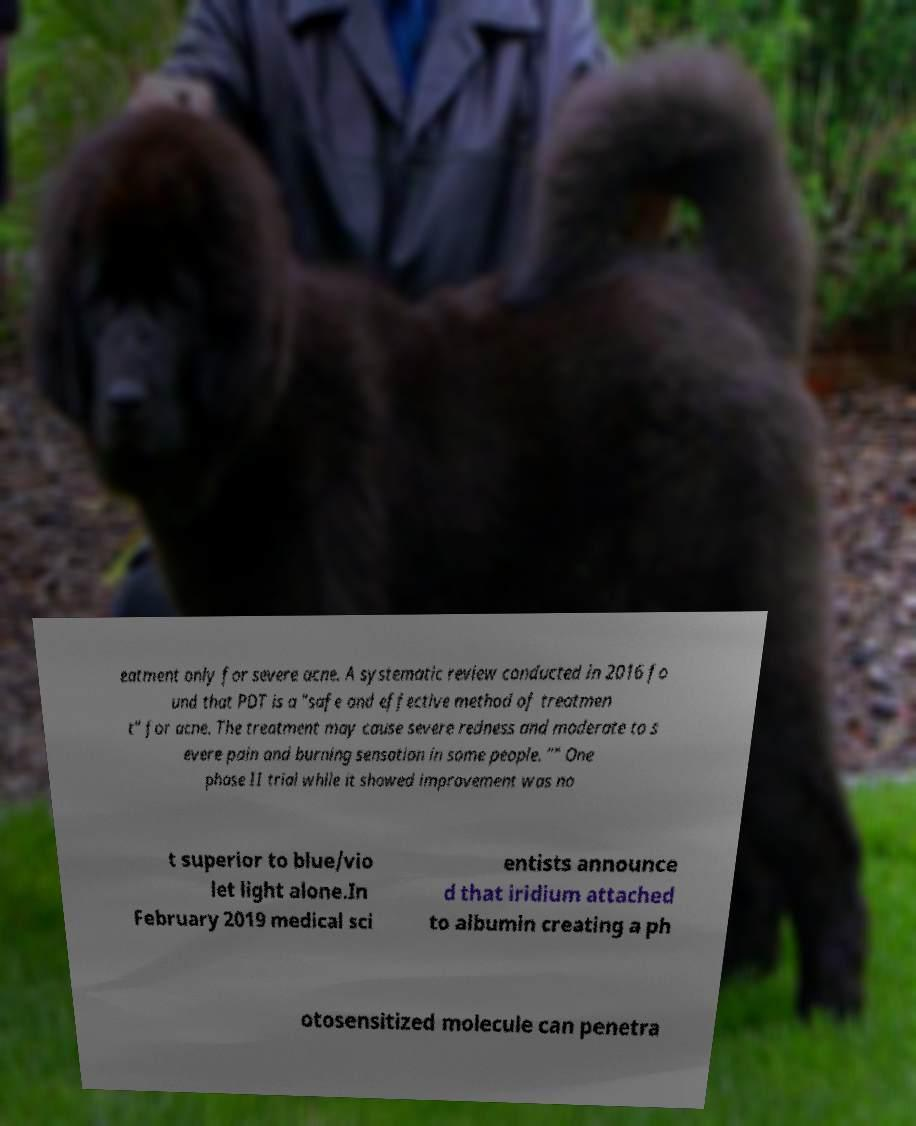Could you assist in decoding the text presented in this image and type it out clearly? eatment only for severe acne. A systematic review conducted in 2016 fo und that PDT is a "safe and effective method of treatmen t" for acne. The treatment may cause severe redness and moderate to s evere pain and burning sensation in some people. "" One phase II trial while it showed improvement was no t superior to blue/vio let light alone.In February 2019 medical sci entists announce d that iridium attached to albumin creating a ph otosensitized molecule can penetra 